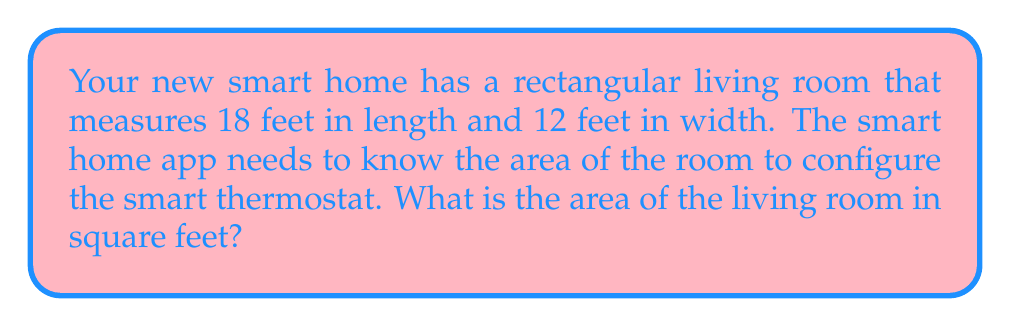Could you help me with this problem? To calculate the area of a rectangular room, we need to multiply its length by its width. Let's break this down step-by-step:

1. Identify the given dimensions:
   - Length ($l$) = 18 feet
   - Width ($w$) = 12 feet

2. Use the formula for the area of a rectangle:
   $$A = l \times w$$
   Where $A$ is the area, $l$ is the length, and $w$ is the width.

3. Substitute the values into the formula:
   $$A = 18 \text{ feet} \times 12 \text{ feet}$$

4. Perform the multiplication:
   $$A = 216 \text{ square feet}$$

The smart home app can now use this area value to optimize the thermostat settings for your living room.
Answer: 216 sq ft 